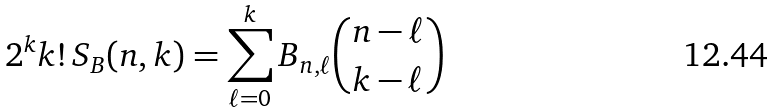<formula> <loc_0><loc_0><loc_500><loc_500>2 ^ { k } k ! \, S _ { B } ( n , k ) = \sum _ { \ell = 0 } ^ { k } B _ { n , \ell } \binom { n - \ell } { k - \ell }</formula> 